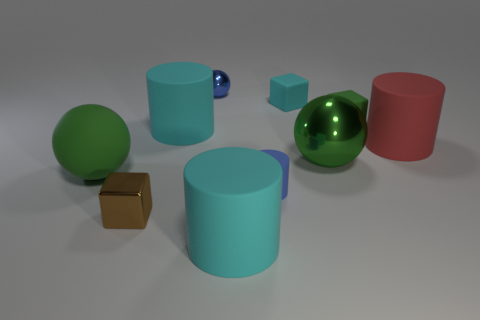Is the number of small cyan matte objects greater than the number of metal objects? No, the number of small cyan matte objects, which includes two items, is not greater than that of the metal objects, since there's only one metallic object visible. 